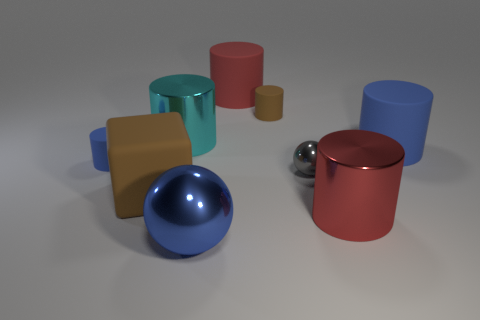Is there a large cyan cylinder that has the same material as the brown cylinder?
Make the answer very short. No. There is a shiny ball that is in front of the rubber cube; is its size the same as the gray object?
Your response must be concise. No. Is there a large red cylinder that is in front of the shiny thing that is behind the blue cylinder that is to the left of the brown matte cylinder?
Ensure brevity in your answer.  Yes. What number of metal things are either big blue objects or cylinders?
Keep it short and to the point. 3. What number of other things are there of the same shape as the red metal thing?
Keep it short and to the point. 5. Is the number of large cyan spheres greater than the number of balls?
Give a very brief answer. No. What is the size of the blue object to the right of the brown rubber thing on the right side of the brown matte block in front of the gray shiny thing?
Your answer should be compact. Large. There is a red thing to the left of the gray metallic sphere; how big is it?
Offer a terse response. Large. How many things are either red matte cylinders or shiny objects behind the big brown thing?
Offer a very short reply. 3. How many other objects are the same size as the brown block?
Provide a succinct answer. 5. 